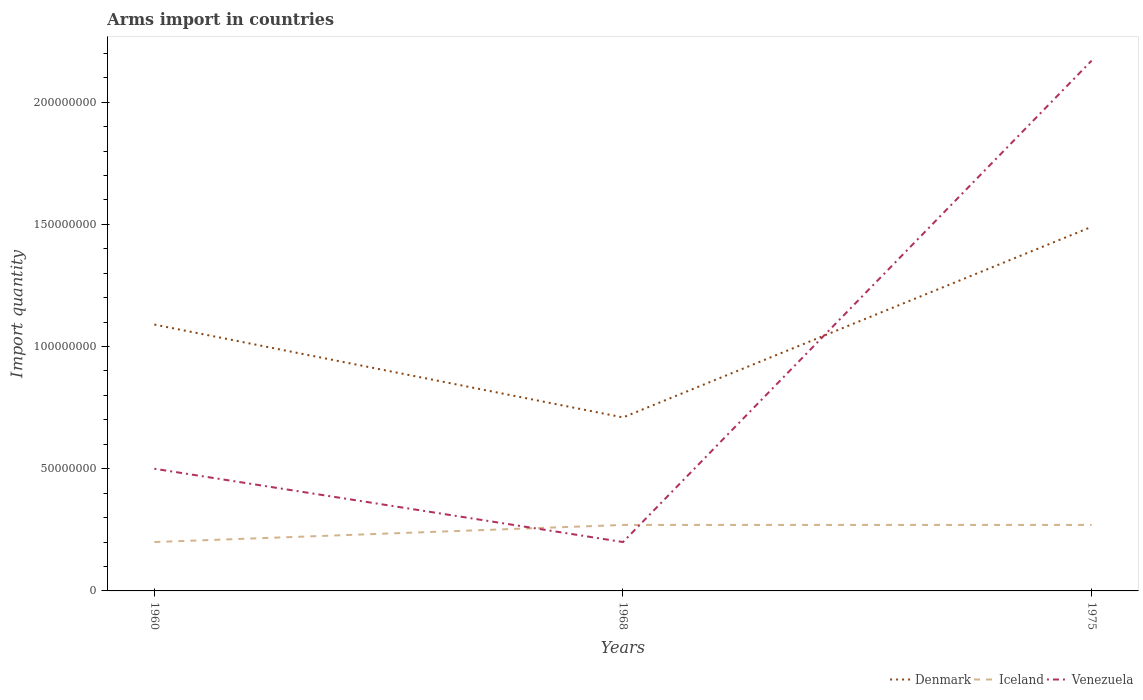How many different coloured lines are there?
Keep it short and to the point. 3. What is the total total arms import in Venezuela in the graph?
Offer a terse response. 3.00e+07. What is the difference between the highest and the second highest total arms import in Venezuela?
Your response must be concise. 1.97e+08. How many lines are there?
Offer a terse response. 3. How many years are there in the graph?
Make the answer very short. 3. Are the values on the major ticks of Y-axis written in scientific E-notation?
Ensure brevity in your answer.  No. Does the graph contain grids?
Your answer should be compact. No. Where does the legend appear in the graph?
Offer a very short reply. Bottom right. How many legend labels are there?
Your response must be concise. 3. What is the title of the graph?
Give a very brief answer. Arms import in countries. What is the label or title of the X-axis?
Offer a very short reply. Years. What is the label or title of the Y-axis?
Ensure brevity in your answer.  Import quantity. What is the Import quantity of Denmark in 1960?
Offer a very short reply. 1.09e+08. What is the Import quantity in Iceland in 1960?
Provide a succinct answer. 2.00e+07. What is the Import quantity of Denmark in 1968?
Make the answer very short. 7.10e+07. What is the Import quantity of Iceland in 1968?
Provide a short and direct response. 2.70e+07. What is the Import quantity of Venezuela in 1968?
Provide a succinct answer. 2.00e+07. What is the Import quantity of Denmark in 1975?
Make the answer very short. 1.49e+08. What is the Import quantity of Iceland in 1975?
Keep it short and to the point. 2.70e+07. What is the Import quantity in Venezuela in 1975?
Offer a very short reply. 2.17e+08. Across all years, what is the maximum Import quantity in Denmark?
Ensure brevity in your answer.  1.49e+08. Across all years, what is the maximum Import quantity of Iceland?
Make the answer very short. 2.70e+07. Across all years, what is the maximum Import quantity of Venezuela?
Offer a terse response. 2.17e+08. Across all years, what is the minimum Import quantity in Denmark?
Give a very brief answer. 7.10e+07. Across all years, what is the minimum Import quantity of Iceland?
Provide a short and direct response. 2.00e+07. What is the total Import quantity in Denmark in the graph?
Offer a terse response. 3.29e+08. What is the total Import quantity of Iceland in the graph?
Ensure brevity in your answer.  7.40e+07. What is the total Import quantity in Venezuela in the graph?
Make the answer very short. 2.87e+08. What is the difference between the Import quantity of Denmark in 1960 and that in 1968?
Your answer should be compact. 3.80e+07. What is the difference between the Import quantity of Iceland in 1960 and that in 1968?
Provide a short and direct response. -7.00e+06. What is the difference between the Import quantity in Venezuela in 1960 and that in 1968?
Offer a very short reply. 3.00e+07. What is the difference between the Import quantity of Denmark in 1960 and that in 1975?
Give a very brief answer. -4.00e+07. What is the difference between the Import quantity in Iceland in 1960 and that in 1975?
Provide a succinct answer. -7.00e+06. What is the difference between the Import quantity of Venezuela in 1960 and that in 1975?
Provide a succinct answer. -1.67e+08. What is the difference between the Import quantity in Denmark in 1968 and that in 1975?
Provide a short and direct response. -7.80e+07. What is the difference between the Import quantity in Iceland in 1968 and that in 1975?
Ensure brevity in your answer.  0. What is the difference between the Import quantity in Venezuela in 1968 and that in 1975?
Your answer should be compact. -1.97e+08. What is the difference between the Import quantity of Denmark in 1960 and the Import quantity of Iceland in 1968?
Provide a short and direct response. 8.20e+07. What is the difference between the Import quantity of Denmark in 1960 and the Import quantity of Venezuela in 1968?
Your answer should be very brief. 8.90e+07. What is the difference between the Import quantity of Iceland in 1960 and the Import quantity of Venezuela in 1968?
Your response must be concise. 0. What is the difference between the Import quantity of Denmark in 1960 and the Import quantity of Iceland in 1975?
Keep it short and to the point. 8.20e+07. What is the difference between the Import quantity of Denmark in 1960 and the Import quantity of Venezuela in 1975?
Your response must be concise. -1.08e+08. What is the difference between the Import quantity of Iceland in 1960 and the Import quantity of Venezuela in 1975?
Keep it short and to the point. -1.97e+08. What is the difference between the Import quantity in Denmark in 1968 and the Import quantity in Iceland in 1975?
Provide a succinct answer. 4.40e+07. What is the difference between the Import quantity in Denmark in 1968 and the Import quantity in Venezuela in 1975?
Your response must be concise. -1.46e+08. What is the difference between the Import quantity of Iceland in 1968 and the Import quantity of Venezuela in 1975?
Offer a very short reply. -1.90e+08. What is the average Import quantity in Denmark per year?
Provide a succinct answer. 1.10e+08. What is the average Import quantity in Iceland per year?
Offer a very short reply. 2.47e+07. What is the average Import quantity of Venezuela per year?
Ensure brevity in your answer.  9.57e+07. In the year 1960, what is the difference between the Import quantity in Denmark and Import quantity in Iceland?
Offer a terse response. 8.90e+07. In the year 1960, what is the difference between the Import quantity of Denmark and Import quantity of Venezuela?
Your answer should be very brief. 5.90e+07. In the year 1960, what is the difference between the Import quantity in Iceland and Import quantity in Venezuela?
Make the answer very short. -3.00e+07. In the year 1968, what is the difference between the Import quantity in Denmark and Import quantity in Iceland?
Ensure brevity in your answer.  4.40e+07. In the year 1968, what is the difference between the Import quantity in Denmark and Import quantity in Venezuela?
Offer a very short reply. 5.10e+07. In the year 1975, what is the difference between the Import quantity of Denmark and Import quantity of Iceland?
Keep it short and to the point. 1.22e+08. In the year 1975, what is the difference between the Import quantity in Denmark and Import quantity in Venezuela?
Ensure brevity in your answer.  -6.80e+07. In the year 1975, what is the difference between the Import quantity of Iceland and Import quantity of Venezuela?
Your response must be concise. -1.90e+08. What is the ratio of the Import quantity of Denmark in 1960 to that in 1968?
Ensure brevity in your answer.  1.54. What is the ratio of the Import quantity in Iceland in 1960 to that in 1968?
Keep it short and to the point. 0.74. What is the ratio of the Import quantity of Denmark in 1960 to that in 1975?
Your answer should be very brief. 0.73. What is the ratio of the Import quantity of Iceland in 1960 to that in 1975?
Keep it short and to the point. 0.74. What is the ratio of the Import quantity in Venezuela in 1960 to that in 1975?
Provide a succinct answer. 0.23. What is the ratio of the Import quantity of Denmark in 1968 to that in 1975?
Offer a terse response. 0.48. What is the ratio of the Import quantity in Venezuela in 1968 to that in 1975?
Make the answer very short. 0.09. What is the difference between the highest and the second highest Import quantity in Denmark?
Provide a succinct answer. 4.00e+07. What is the difference between the highest and the second highest Import quantity in Iceland?
Your answer should be very brief. 0. What is the difference between the highest and the second highest Import quantity of Venezuela?
Ensure brevity in your answer.  1.67e+08. What is the difference between the highest and the lowest Import quantity of Denmark?
Your answer should be very brief. 7.80e+07. What is the difference between the highest and the lowest Import quantity in Iceland?
Ensure brevity in your answer.  7.00e+06. What is the difference between the highest and the lowest Import quantity in Venezuela?
Provide a short and direct response. 1.97e+08. 